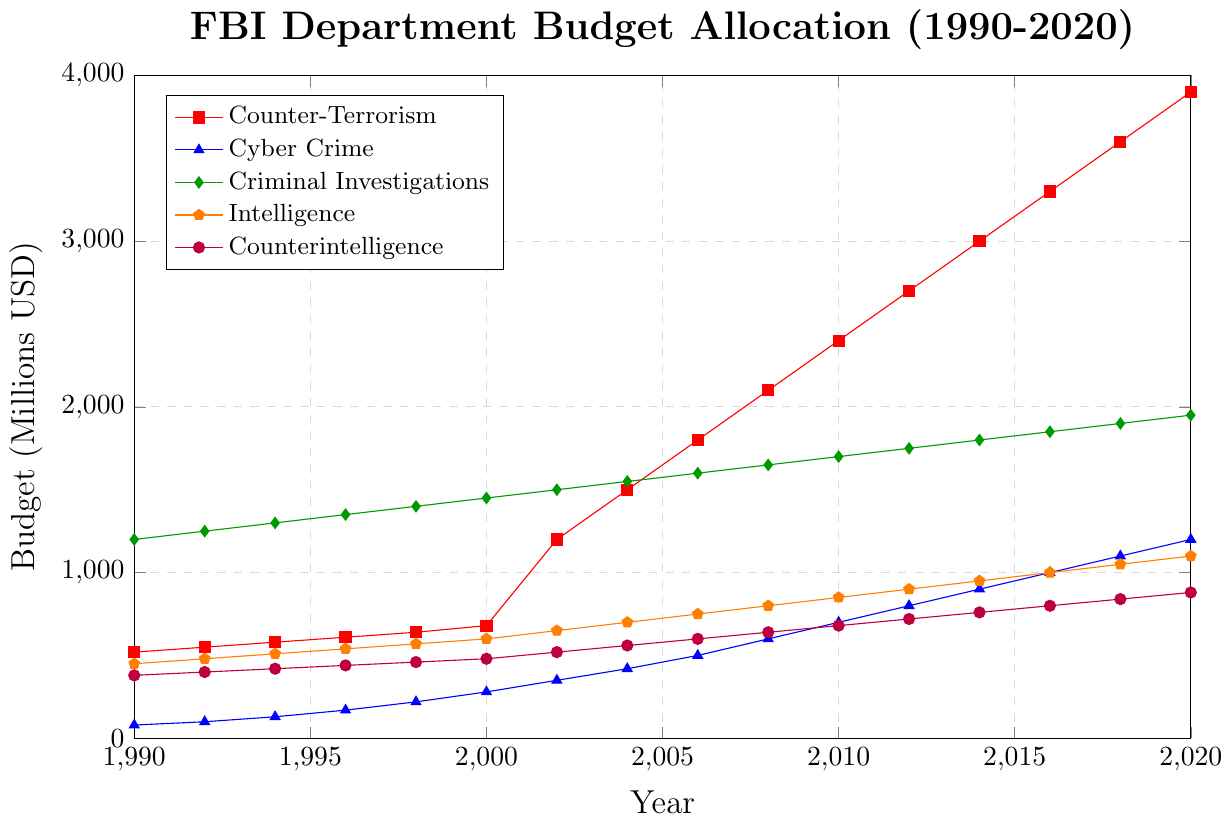Which department had the highest budget allocation in 1990? Looking at the budget values for each department in 1990, Criminal Investigations had the highest value at 1200 million USD.
Answer: Criminal Investigations By how much did the budget for Counter-Terrorism increase from 2000 to 2020? The budget for Counter-Terrorism in 2000 was 680 million USD, and in 2020 it was 3900 million USD. The increase is calculated as 3900 - 680 = 3220 million USD.
Answer: 3220 million USD Which department had the lowest budget allocation in 2010, and what was the amount? Observing the budgets in 2010, Cyber Crime had the lowest budget allocation at 700 million USD.
Answer: Cyber Crime, 700 million USD Compare the budget for Intelligence and Counterintelligence in 2016. Which one was higher and by how much? The budget for Intelligence in 2016 was 1000 million USD, while the budget for Counterintelligence was 800 million USD. The difference is 1000 - 800 = 200 million USD. Intelligence had a higher budget by 200 million USD.
Answer: Intelligence, 200 million USD Calculate the average annual budget for Cyber Crime from 2000 to 2020. Adding the budgets for Cyber Crime from 2000 (280) to 2020 (1200): 280 + 350 + 420 + 500 + 600 + 700 + 800 + 900 + 1000 + 1100 + 1200 = 7850. There are 11 values, so the average is 7850 / 11 ≈ 713.64 million USD.
Answer: 713.64 million USD Between 2008 and 2012, which department showed the greatest budget increase, and by how much? Calculating the budget increases between 2008 and 2012: Counter-Terrorism (2700 - 2100 = 600), Cyber Crime (800 - 600 = 200), Criminal Investigations (1750 - 1650 = 100), Intelligence (900 - 800 = 100), Counterintelligence (720 - 640 = 80). Counter-Terrorism had the greatest increase of 600 million USD.
Answer: Counter-Terrorism, 600 million USD Which department had a budget exactly halfway between its starting and ending values in 2010? Calculating halfway points: Counter-Terrorism (520 + 3900) / 2 = 2210; Cyber Crime (80 + 1200) / 2 = 640; Criminal Investigations (1200 + 1950) / 2 = 1575; Intelligence (450 + 1100) / 2 = 775; Counterintelligence (380 + 880) / 2 = 630. Only Cyber Crime shows a budget close to 640 in 2010.
Answer: Cyber Crime Which color represents the Counterintelligence budget trend, and what is its value in 2006? The Counterintelligence budget trend is represented by the purple line. The budget in 2006 is shown as 600 million USD.
Answer: Purple, 600 million USD 